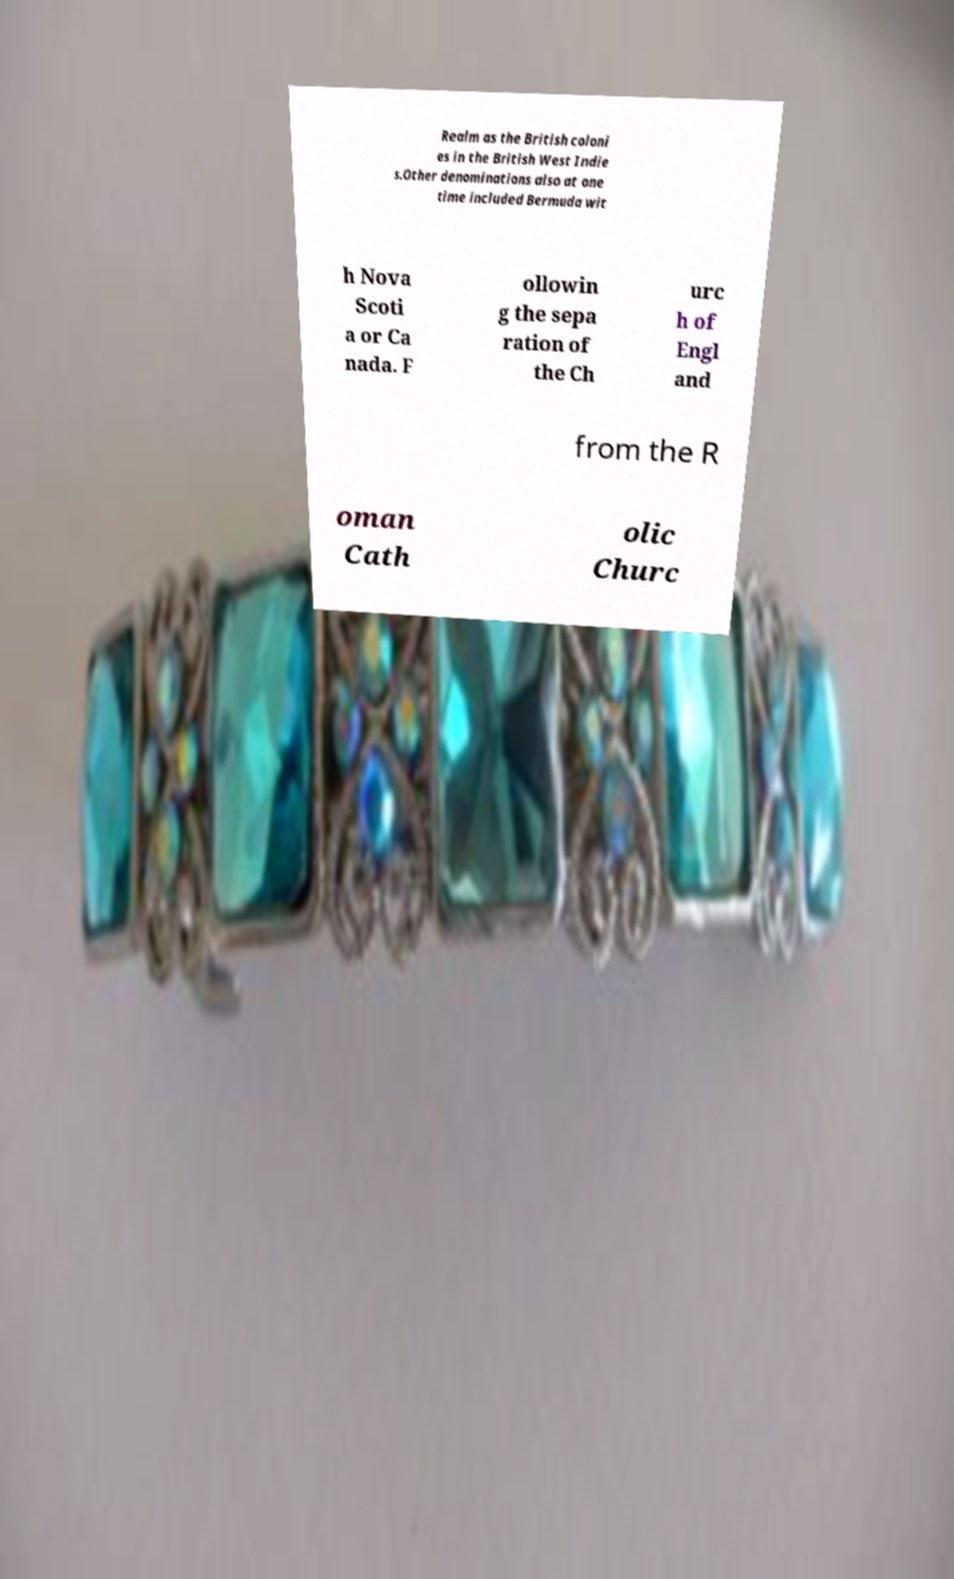For documentation purposes, I need the text within this image transcribed. Could you provide that? Realm as the British coloni es in the British West Indie s.Other denominations also at one time included Bermuda wit h Nova Scoti a or Ca nada. F ollowin g the sepa ration of the Ch urc h of Engl and from the R oman Cath olic Churc 